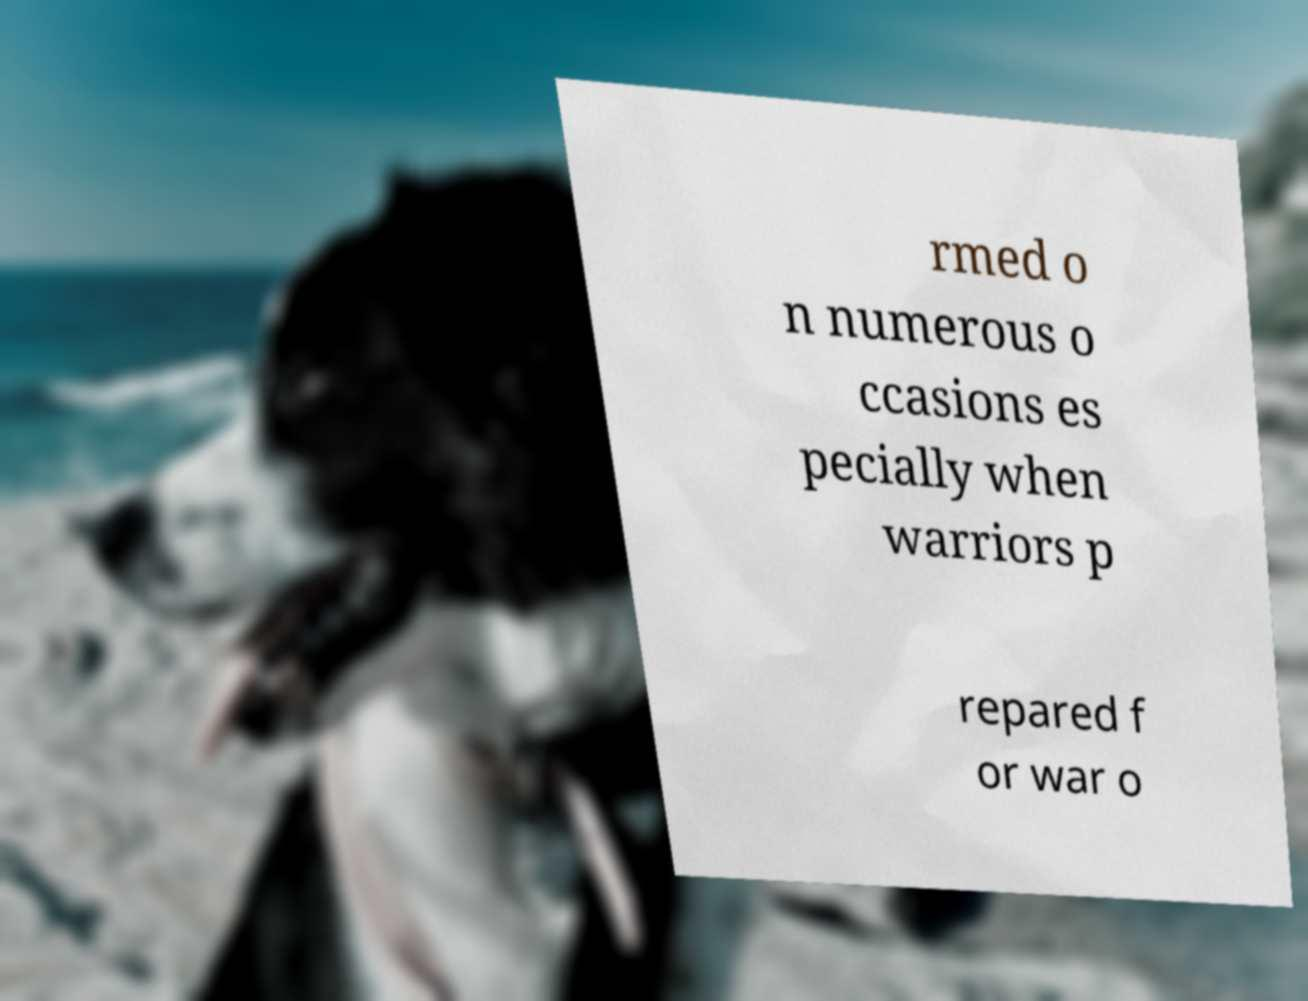Can you read and provide the text displayed in the image?This photo seems to have some interesting text. Can you extract and type it out for me? rmed o n numerous o ccasions es pecially when warriors p repared f or war o 